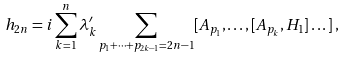<formula> <loc_0><loc_0><loc_500><loc_500>h _ { 2 n } = i \sum _ { k = 1 } ^ { n } \lambda _ { k } ^ { \prime } \sum _ { p _ { 1 } + \dots + p _ { 2 k - 1 } = 2 n - 1 } [ A _ { p _ { 1 } } , \dots , [ A _ { p _ { k } } , H _ { 1 } ] \dots ] \, ,</formula> 